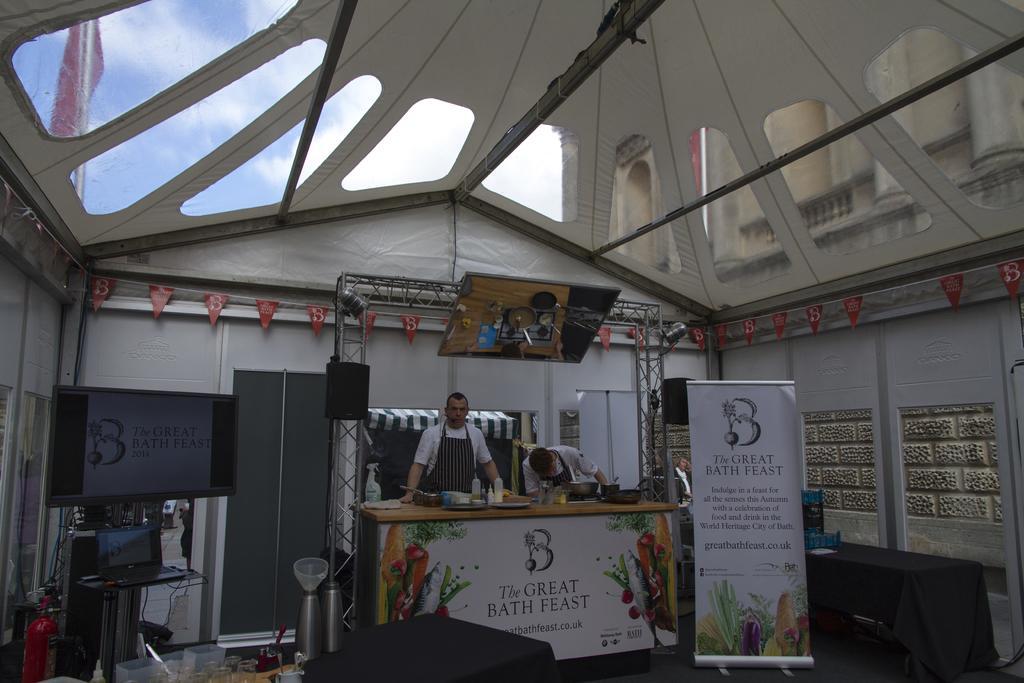In one or two sentences, can you explain what this image depicts? In this picture we can see two persons standing and in front of them there is table and on table we have vessel, bottle,bowl, stove and beside to them banner, screen, laptop, boxes, fire extinguisher and at top sky, roof. 